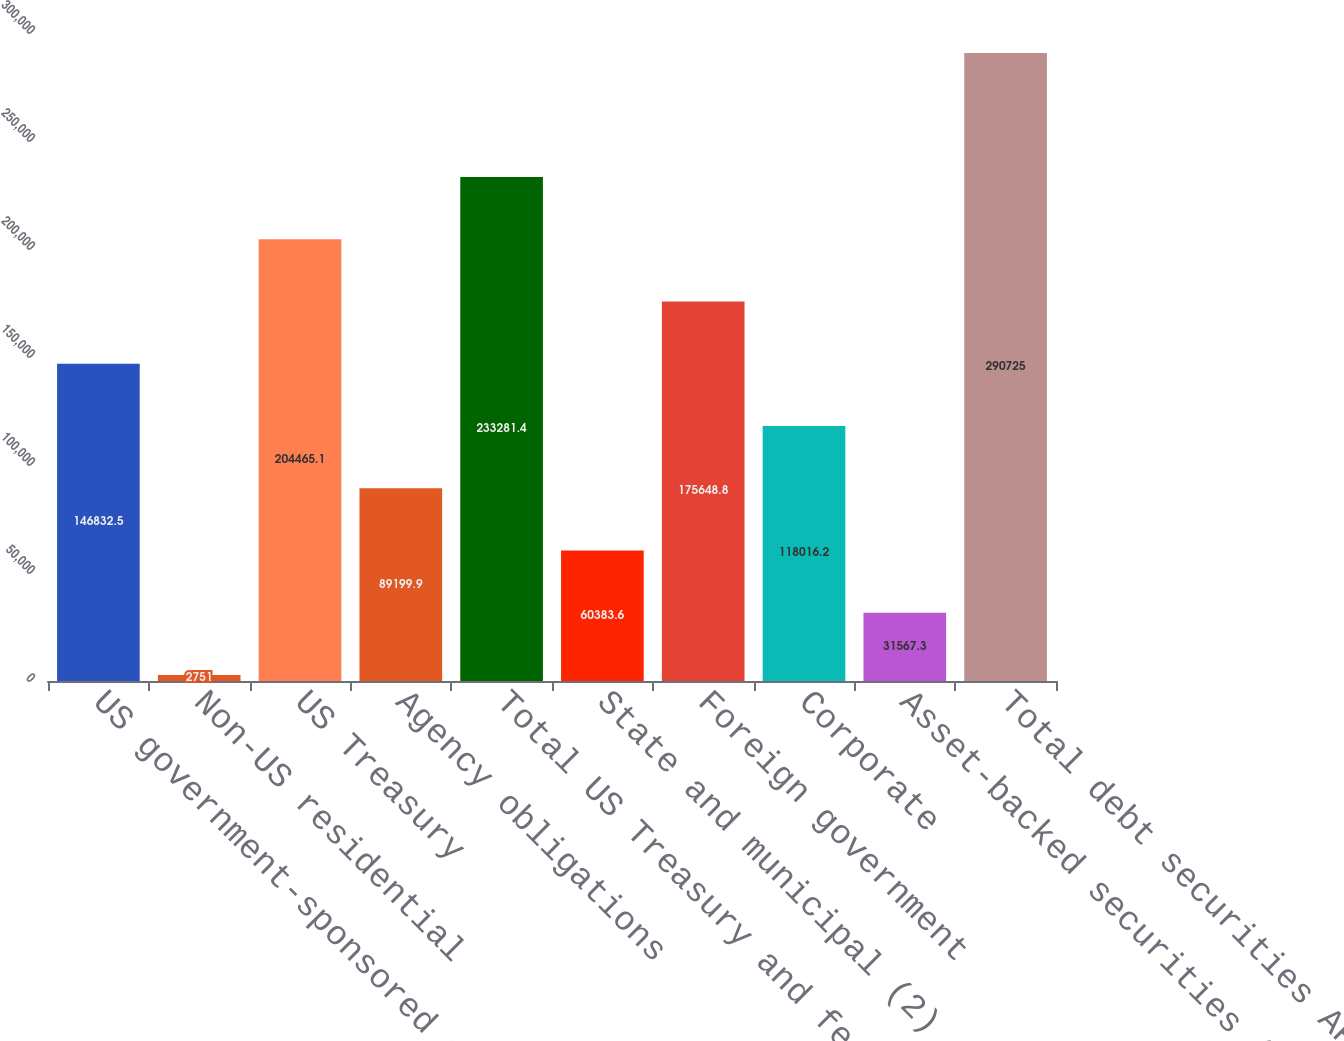Convert chart. <chart><loc_0><loc_0><loc_500><loc_500><bar_chart><fcel>US government-sponsored agency<fcel>Non-US residential<fcel>US Treasury<fcel>Agency obligations<fcel>Total US Treasury and federal<fcel>State and municipal (2)<fcel>Foreign government<fcel>Corporate<fcel>Asset-backed securities (1)<fcel>Total debt securities AFS<nl><fcel>146832<fcel>2751<fcel>204465<fcel>89199.9<fcel>233281<fcel>60383.6<fcel>175649<fcel>118016<fcel>31567.3<fcel>290725<nl></chart> 